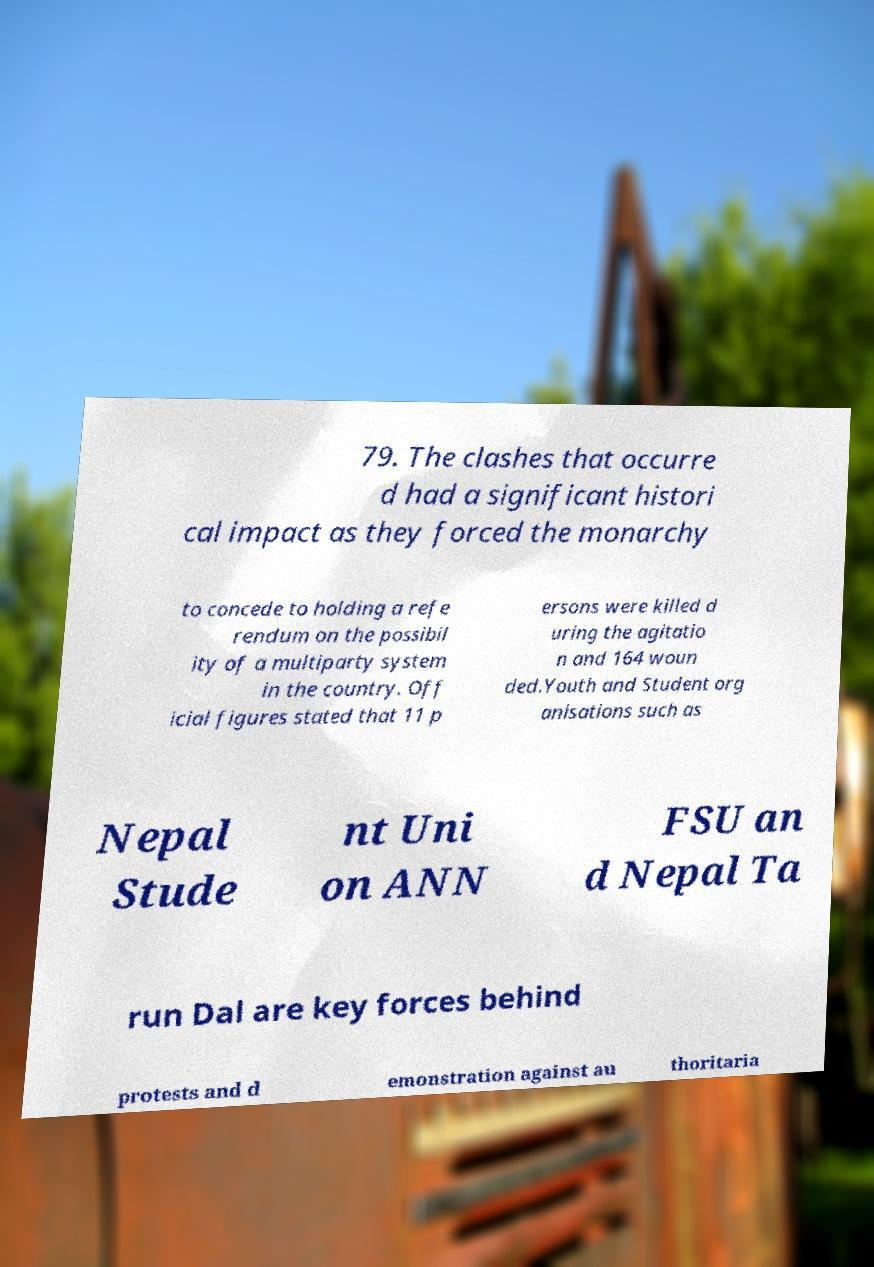Please identify and transcribe the text found in this image. 79. The clashes that occurre d had a significant histori cal impact as they forced the monarchy to concede to holding a refe rendum on the possibil ity of a multiparty system in the country. Off icial figures stated that 11 p ersons were killed d uring the agitatio n and 164 woun ded.Youth and Student org anisations such as Nepal Stude nt Uni on ANN FSU an d Nepal Ta run Dal are key forces behind protests and d emonstration against au thoritaria 